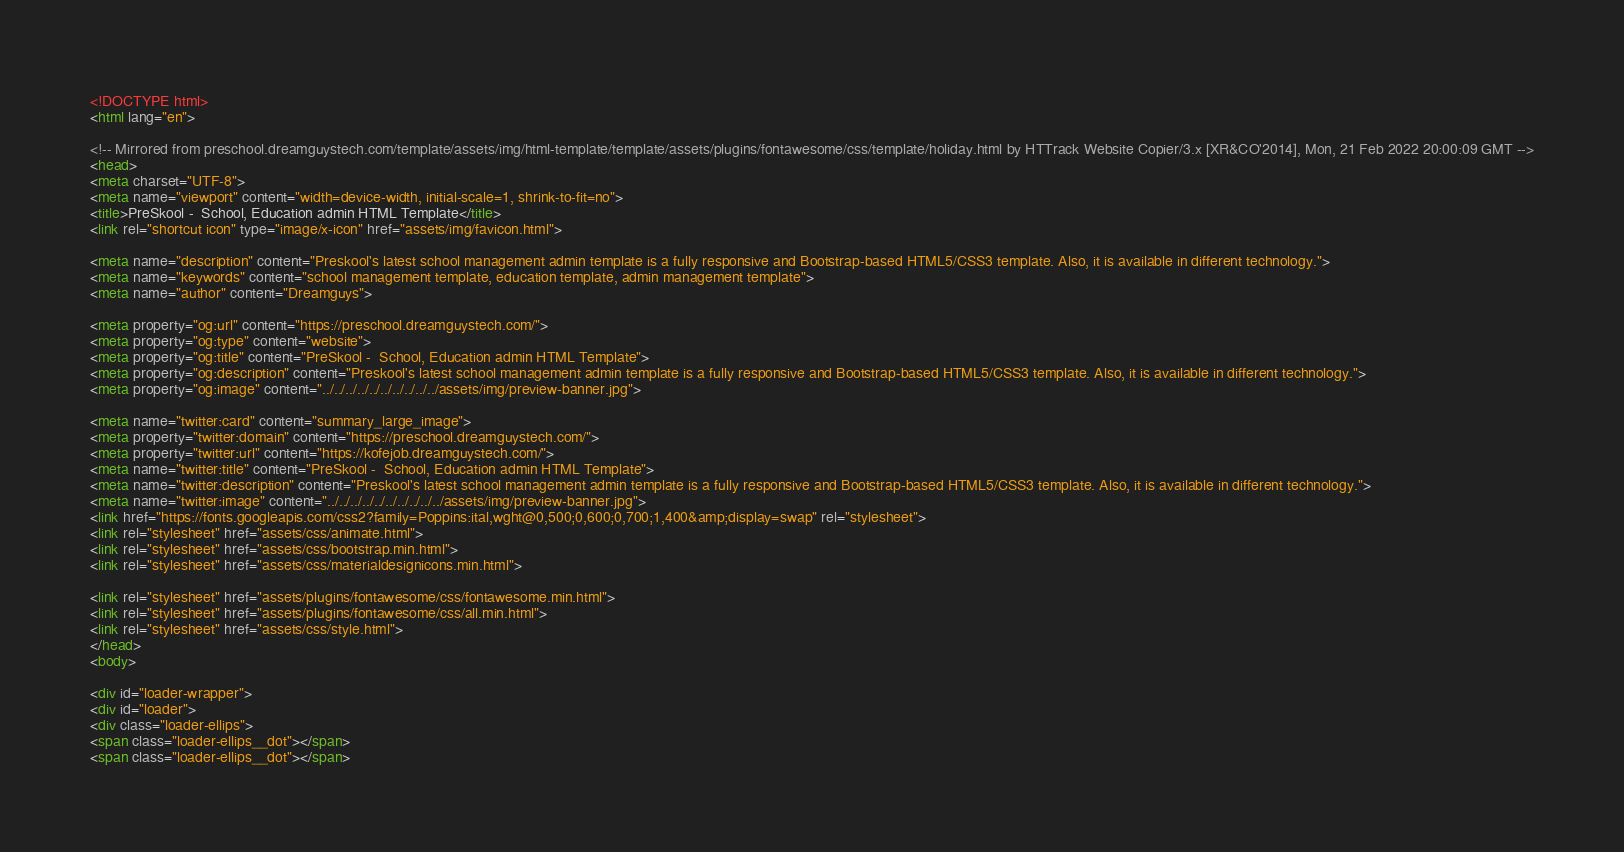<code> <loc_0><loc_0><loc_500><loc_500><_HTML_><!DOCTYPE html>
<html lang="en">

<!-- Mirrored from preschool.dreamguystech.com/template/assets/img/html-template/template/assets/plugins/fontawesome/css/template/holiday.html by HTTrack Website Copier/3.x [XR&CO'2014], Mon, 21 Feb 2022 20:00:09 GMT -->
<head>
<meta charset="UTF-8">
<meta name="viewport" content="width=device-width, initial-scale=1, shrink-to-fit=no">
<title>PreSkool -  School, Education admin HTML Template</title>
<link rel="shortcut icon" type="image/x-icon" href="assets/img/favicon.html">

<meta name="description" content="Preskool's latest school management admin template is a fully responsive and Bootstrap-based HTML5/CSS3 template. Also, it is available in different technology.">
<meta name="keywords" content="school management template, education template, admin management template">
<meta name="author" content="Dreamguys">

<meta property="og:url" content="https://preschool.dreamguystech.com/">
<meta property="og:type" content="website">
<meta property="og:title" content="PreSkool -  School, Education admin HTML Template">
<meta property="og:description" content="Preskool's latest school management admin template is a fully responsive and Bootstrap-based HTML5/CSS3 template. Also, it is available in different technology.">
<meta property="og:image" content="../../../../../../../../../../assets/img/preview-banner.jpg">

<meta name="twitter:card" content="summary_large_image">
<meta property="twitter:domain" content="https://preschool.dreamguystech.com/">
<meta property="twitter:url" content="https://kofejob.dreamguystech.com/">
<meta name="twitter:title" content="PreSkool -  School, Education admin HTML Template">
<meta name="twitter:description" content="Preskool's latest school management admin template is a fully responsive and Bootstrap-based HTML5/CSS3 template. Also, it is available in different technology.">
<meta name="twitter:image" content="../../../../../../../../../../assets/img/preview-banner.jpg">
<link href="https://fonts.googleapis.com/css2?family=Poppins:ital,wght@0,500;0,600;0,700;1,400&amp;display=swap" rel="stylesheet">
<link rel="stylesheet" href="assets/css/animate.html">
<link rel="stylesheet" href="assets/css/bootstrap.min.html">
<link rel="stylesheet" href="assets/css/materialdesignicons.min.html">

<link rel="stylesheet" href="assets/plugins/fontawesome/css/fontawesome.min.html">
<link rel="stylesheet" href="assets/plugins/fontawesome/css/all.min.html">
<link rel="stylesheet" href="assets/css/style.html">
</head>
<body>

<div id="loader-wrapper">
<div id="loader">
<div class="loader-ellips">
<span class="loader-ellips__dot"></span>
<span class="loader-ellips__dot"></span></code> 